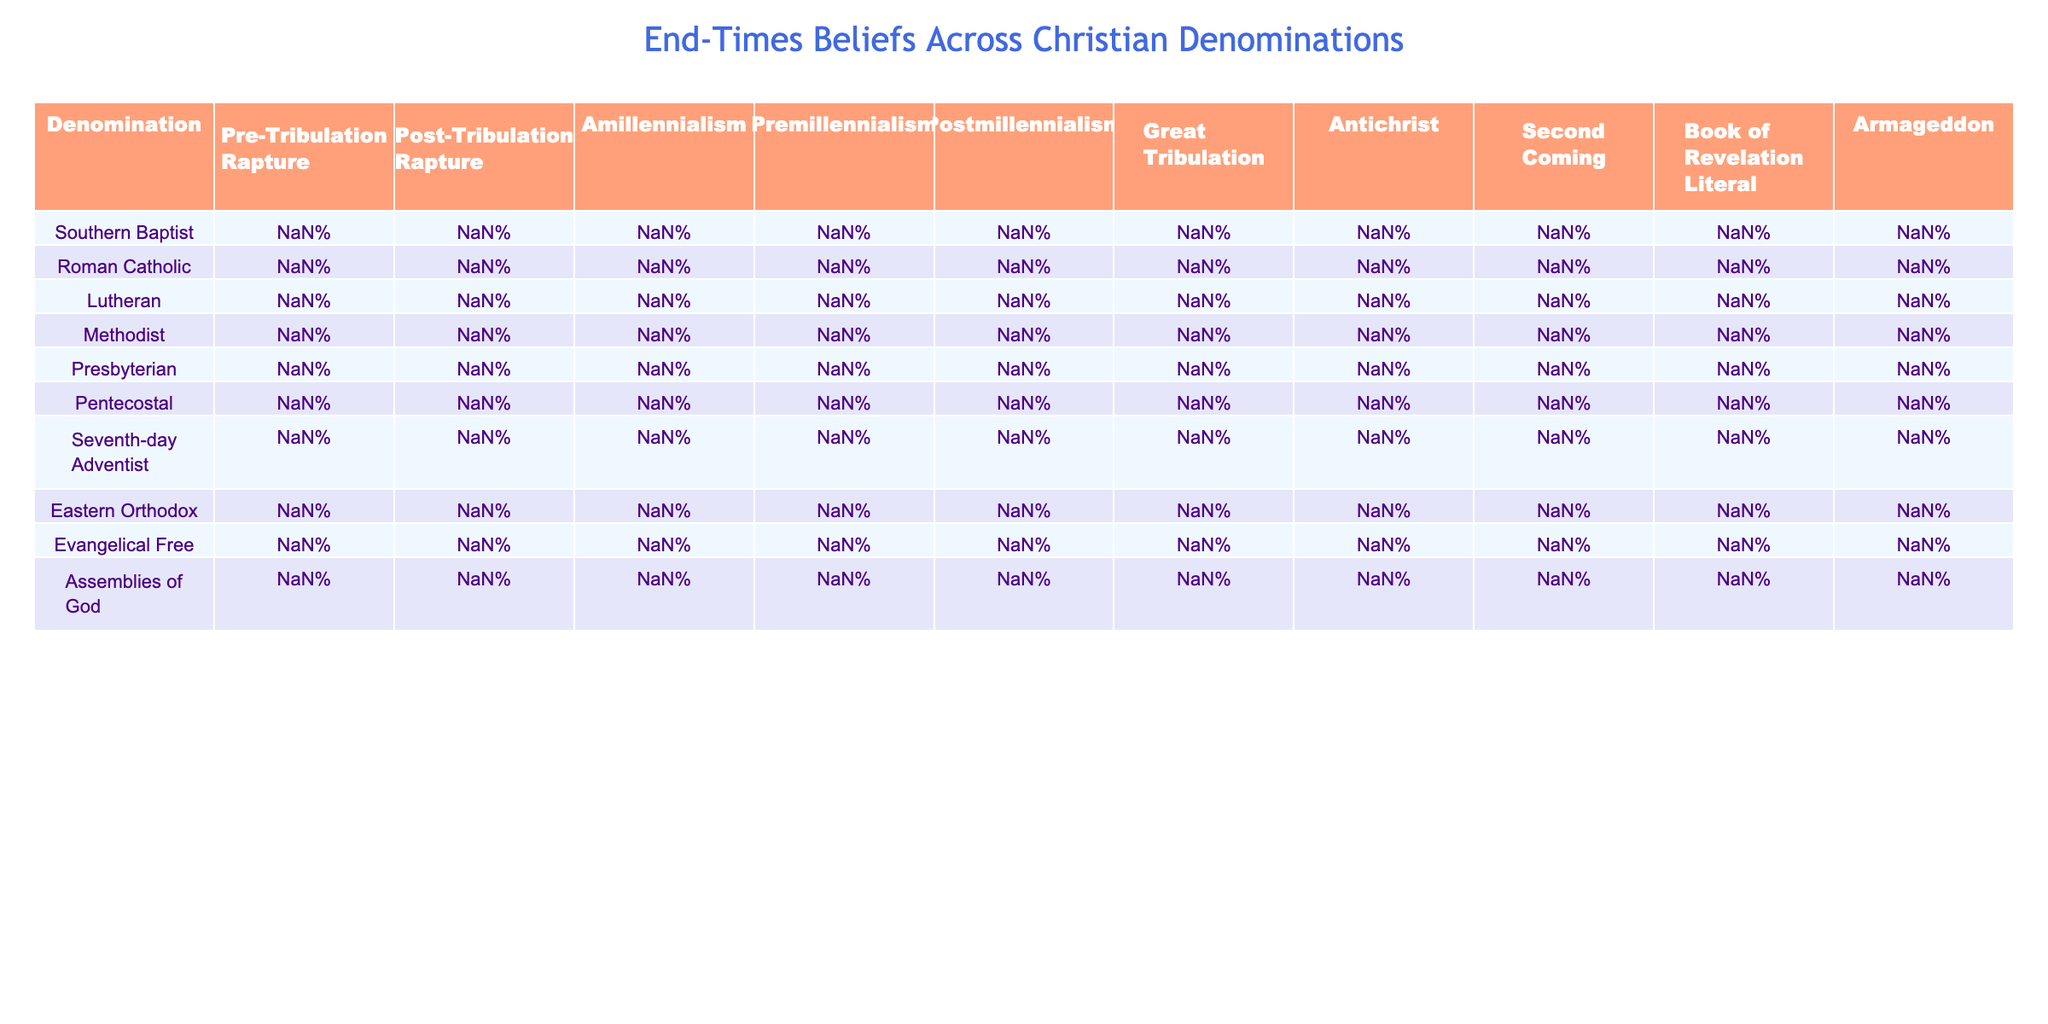What percentage of Pentecostals believe in a Pre-Tribulation Rapture? According to the table, 95% of Pentecostals believe in a Pre-Tribulation Rapture.
Answer: 95% Which denomination has the highest belief in Post-Tribulation Rapture? The Seventh-day Adventist denomination has the highest belief in Post-Tribulation Rapture at 90%.
Answer: 90% Is it true that more than 70% of Lutherans believe in Amillennialism? The table shows that 50% of Lutherans believe in Amillennialism, which is not more than 70%. Thus, it is false.
Answer: False What is the difference in belief of the Great Tribulation between Southern Baptist and Roman Catholic denominations? Southern Baptists believe 95% in the Great Tribulation, while Roman Catholics believe 70%. The difference is 95% - 70% = 25%.
Answer: 25% Which denomination has the lowest belief in Premillennialism? The Presbyterian denomination has the lowest belief in Premillennialism at 10%.
Answer: 10% What is the average percentage of belief in the Second Coming among the denominations listed? The percentages for the Second Coming are 100%, 98%, 99%, 98%, 97%, 100%, 80%, 95%, 85%, and 96%. Adding them gives 980% and dividing by 10 denominations gives an average of 98%.
Answer: 98% How many denominations have more than 50% belief in the Book of Revelation being literal? Examining the percentages, Southern Baptist (100%), Pentecostal (100%), Assemblies of God (100%), Evangelical Free (100%), and Lutheran (99%) all have more than 50%. This results in 5 denominations.
Answer: 5 What percentage of the Roman Catholic denomination believes in Postmillennialism? The table indicates that 20% of the Roman Catholic denomination believes in Postmillennialism.
Answer: 20% Which denomination has the second highest belief in Antichrist? Pentecostal has the highest belief in Antichrist at 99%, and the next highest is Southern Baptist at 98%. Therefore, Southern Baptist is the second highest.
Answer: Southern Baptist Calculate the total percentage of belief in the Pre-Tribulation and Post-Tribulation Rapture for the Evangelical Free denomination. The Evangelical Free belief in Pre-Tribulation Rapture is 85% and in Post-Tribulation Rapture is 10%. The total is 85% + 10% = 95%.
Answer: 95% Which denomination has a belief in Armageddon closest to 90%? The Assemblies of God has a belief in Armageddon at 96%, which is closest to 90%.
Answer: Assemblies of God 